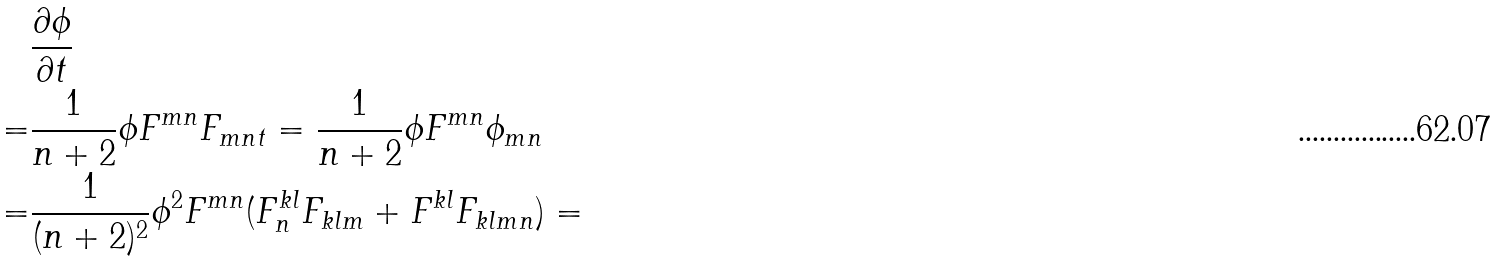Convert formula to latex. <formula><loc_0><loc_0><loc_500><loc_500>& \frac { \partial \phi } { \partial t } \\ = & { \frac { 1 } { n + 2 } } \phi F ^ { m n } F _ { m n t } = { \frac { 1 } { n + 2 } } \phi F ^ { m n } \phi _ { m n } \\ = & { \frac { 1 } { ( n + 2 ) ^ { 2 } } } \phi ^ { 2 } F ^ { m n } ( F ^ { k l } _ { n } F _ { k l m } + F ^ { k l } F _ { k l m n } ) =</formula> 